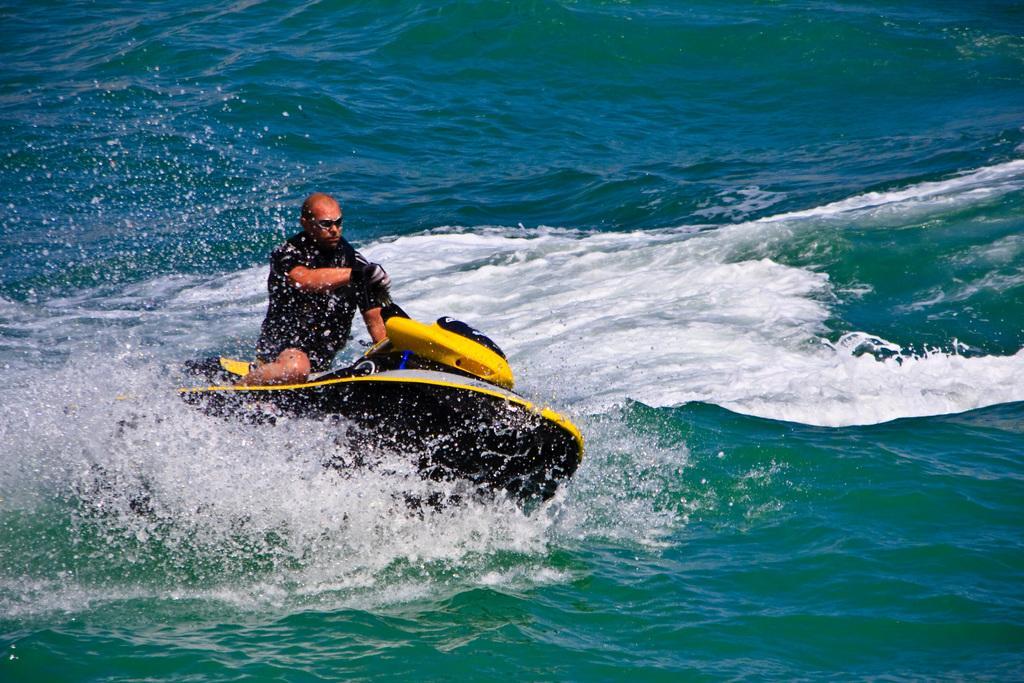Please provide a concise description of this image. In the center of the image a man is riding a boat. In the background of the image we can see water. 